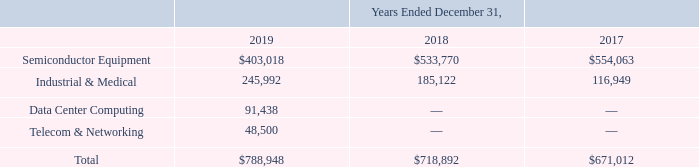ADVANCED ENERGY INDUSTRIES, INC. NOTES TO CONSOLIDATED FINANCIAL STATEMENTS – (continued) (in thousands, except per share amounts)
Disaggregation of Revenue
The following table presents our sales by product line, which includes certain reclassifications to prior comparative periods to conform to our current year presentation:
What was the sales for Semiconductor Equipment in 2017?
Answer scale should be: thousand. $554,063. What was the sales for Industrial & Medical in 2017?
Answer scale should be: thousand. 116,949. What was the sales for Data Center Computing in 2019?
Answer scale should be: thousand. 91,438. What was the change in sales of Industrial & Medical products between 2018 and 2019? 
Answer scale should be: thousand. 245,992-185,122
Answer: 60870. What was the change in sales of Semiconductor Equipment between 2017 and 2018?
Answer scale should be: thousand. $533,770-$554,063
Answer: -20293. What was the percentage change in total sales between 2018 and 2019?
Answer scale should be: percent. ($788,948-$718,892)/718,892
Answer: 9.74. 